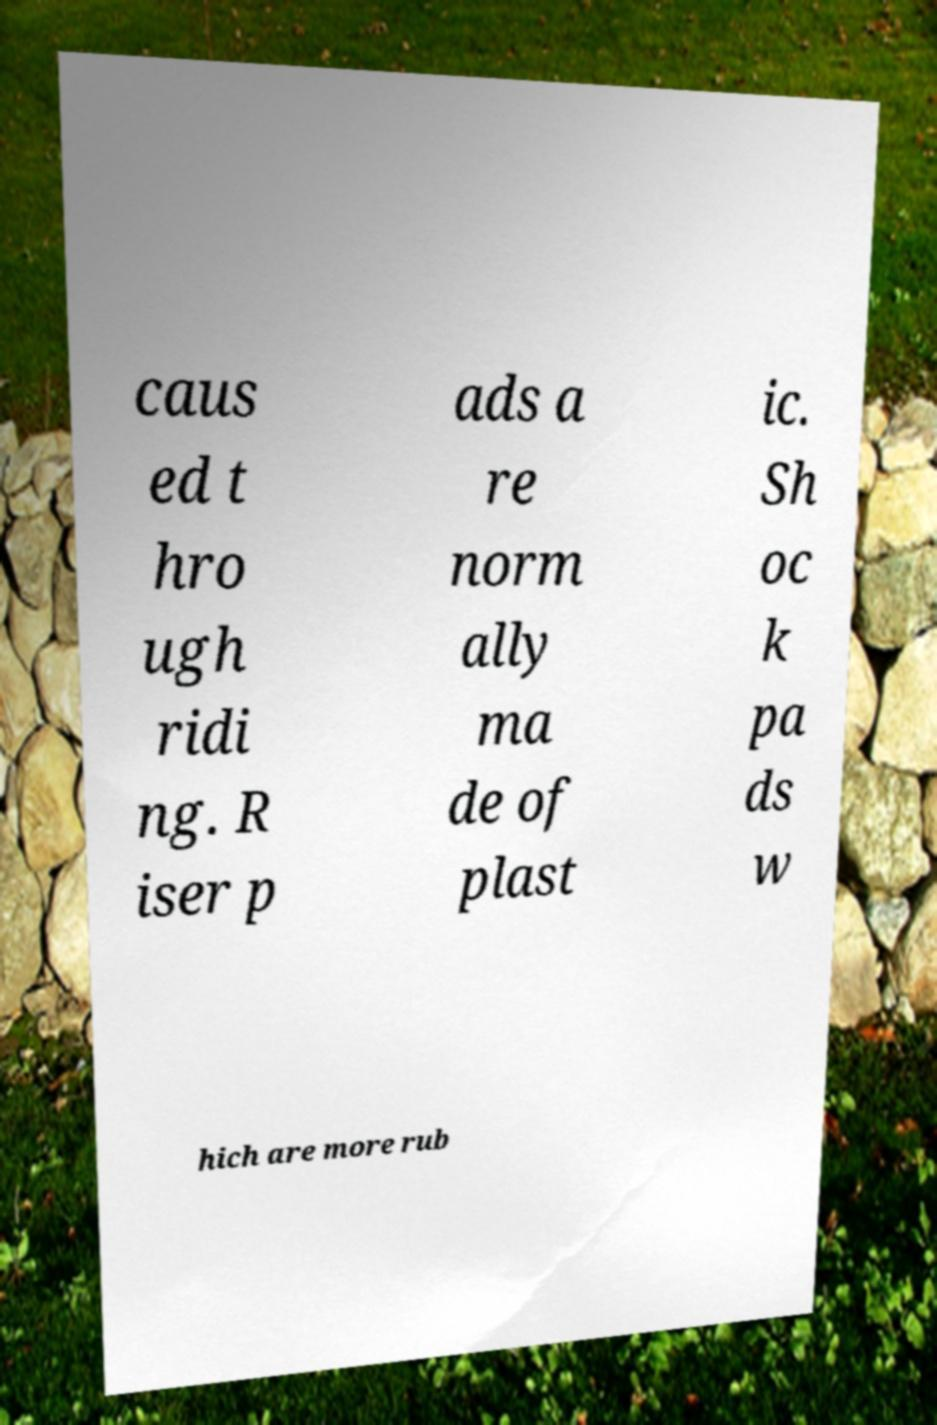Can you read and provide the text displayed in the image?This photo seems to have some interesting text. Can you extract and type it out for me? caus ed t hro ugh ridi ng. R iser p ads a re norm ally ma de of plast ic. Sh oc k pa ds w hich are more rub 